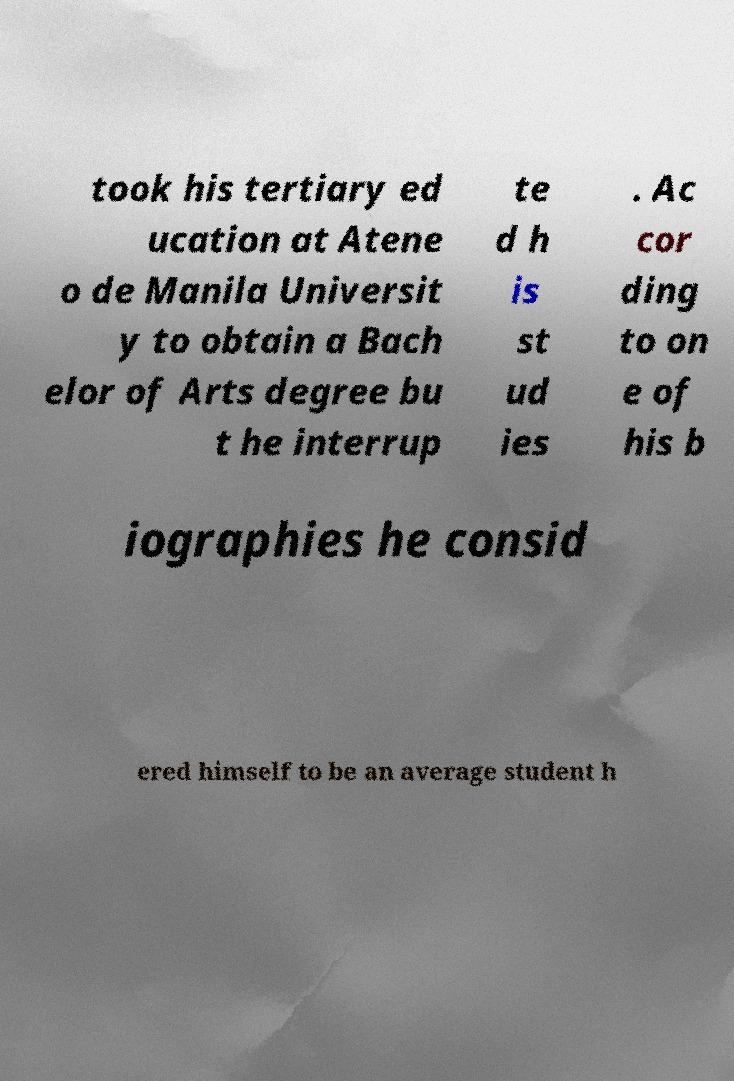Please read and relay the text visible in this image. What does it say? took his tertiary ed ucation at Atene o de Manila Universit y to obtain a Bach elor of Arts degree bu t he interrup te d h is st ud ies . Ac cor ding to on e of his b iographies he consid ered himself to be an average student h 